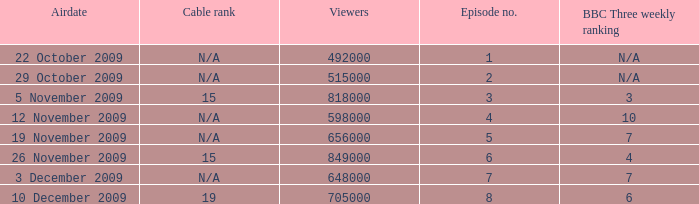I'm looking to parse the entire table for insights. Could you assist me with that? {'header': ['Airdate', 'Cable rank', 'Viewers', 'Episode no.', 'BBC Three weekly ranking'], 'rows': [['22 October 2009', 'N/A', '492000', '1', 'N/A'], ['29 October 2009', 'N/A', '515000', '2', 'N/A'], ['5 November 2009', '15', '818000', '3', '3'], ['12 November 2009', 'N/A', '598000', '4', '10'], ['19 November 2009', 'N/A', '656000', '5', '7'], ['26 November 2009', '15', '849000', '6', '4'], ['3 December 2009', 'N/A', '648000', '7', '7'], ['10 December 2009', '19', '705000', '8', '6']]} What is the cable rank for bbc three weekly ranking of n/a? N/A, N/A. 